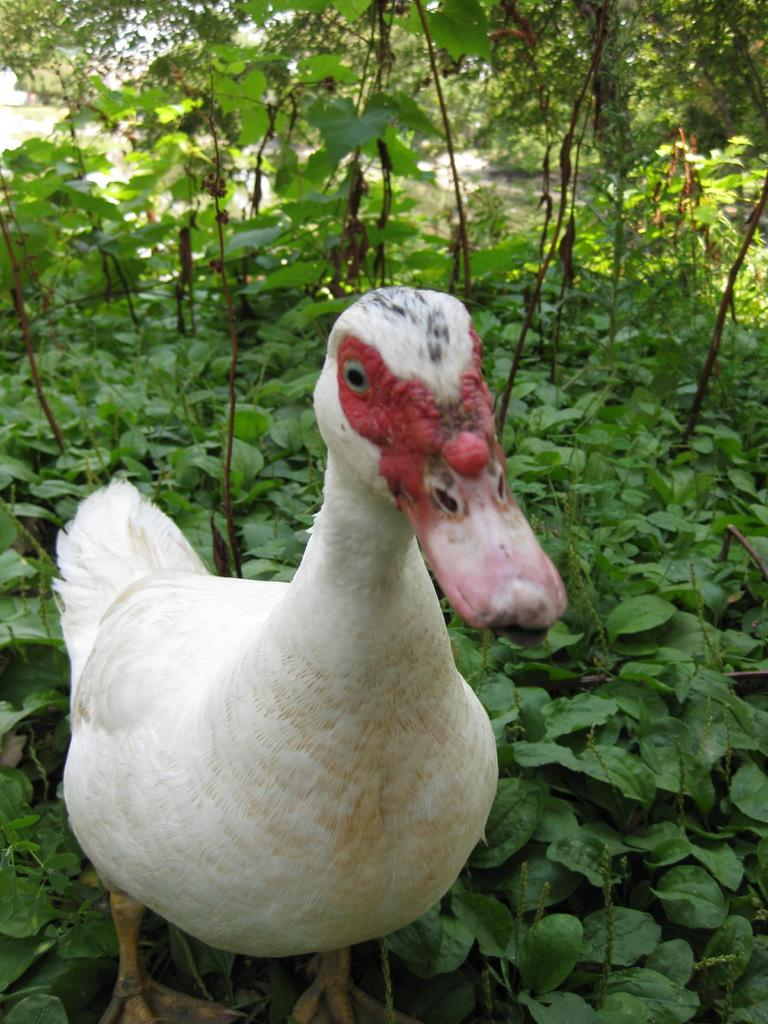What type of animal is present in the image? There is a hen in the image. What else can be seen in the image besides the hen? There are plants in the image. What type of structure can be seen in the background of the image? There is no structure visible in the image; it only features a hen and plants. Are there any potatoes present in the image? There are no potatoes present in the image. 